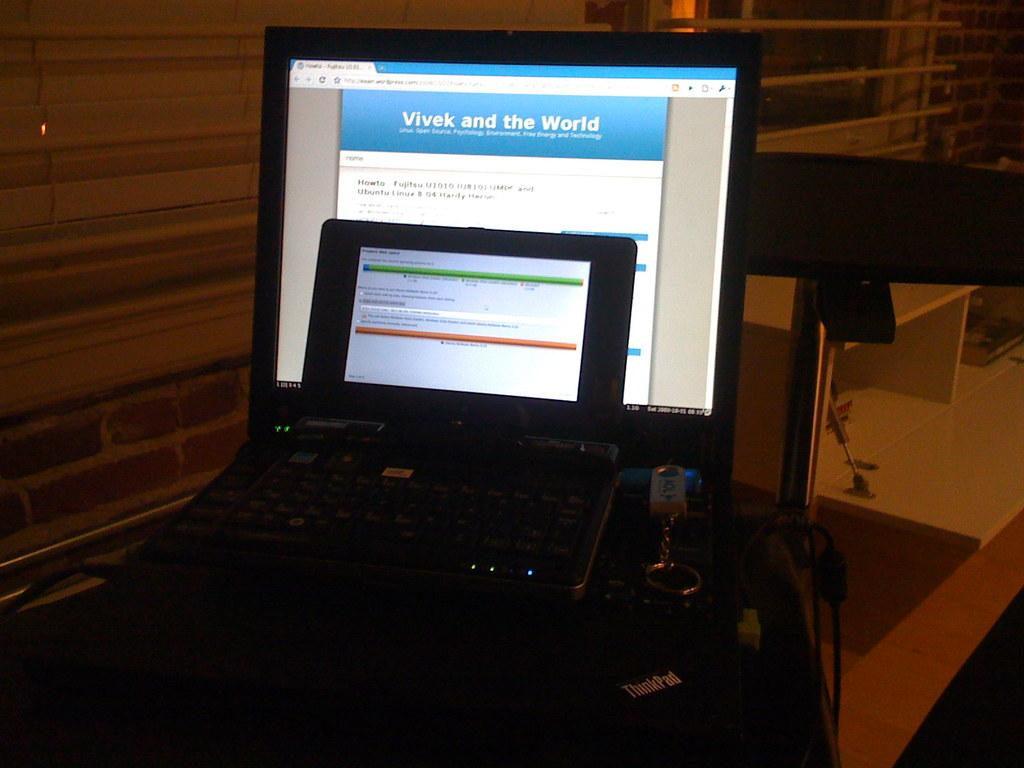<image>
Offer a succinct explanation of the picture presented. A Thinkpad computer opened to a webpage called Vivek and the World. 